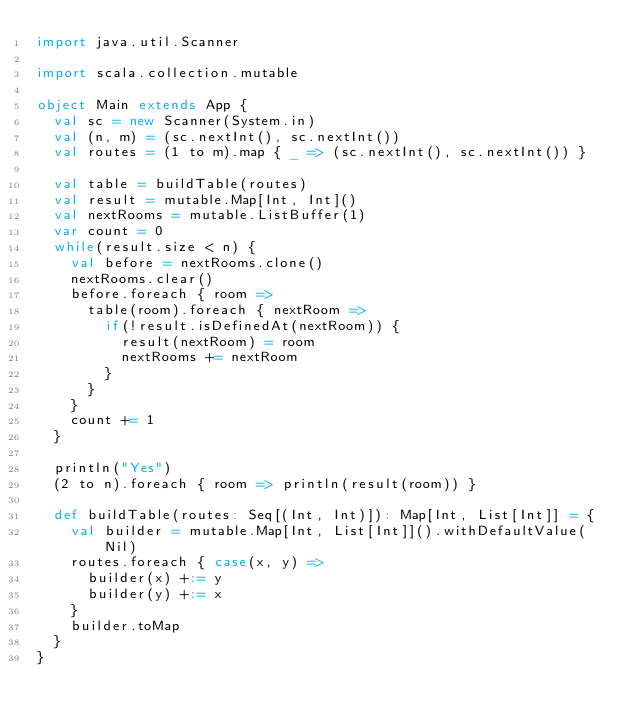<code> <loc_0><loc_0><loc_500><loc_500><_Scala_>import java.util.Scanner

import scala.collection.mutable

object Main extends App {
  val sc = new Scanner(System.in)
  val (n, m) = (sc.nextInt(), sc.nextInt())
  val routes = (1 to m).map { _ => (sc.nextInt(), sc.nextInt()) }

  val table = buildTable(routes)
  val result = mutable.Map[Int, Int]()
  val nextRooms = mutable.ListBuffer(1)
  var count = 0
  while(result.size < n) {
    val before = nextRooms.clone()
    nextRooms.clear()
    before.foreach { room =>
      table(room).foreach { nextRoom =>
        if(!result.isDefinedAt(nextRoom)) {
          result(nextRoom) = room
          nextRooms += nextRoom
        }
      }
    }
    count += 1
  }

  println("Yes")
  (2 to n).foreach { room => println(result(room)) }

  def buildTable(routes: Seq[(Int, Int)]): Map[Int, List[Int]] = {
    val builder = mutable.Map[Int, List[Int]]().withDefaultValue(Nil)
    routes.foreach { case(x, y) =>
      builder(x) +:= y
      builder(y) +:= x
    }
    builder.toMap
  }
}
</code> 